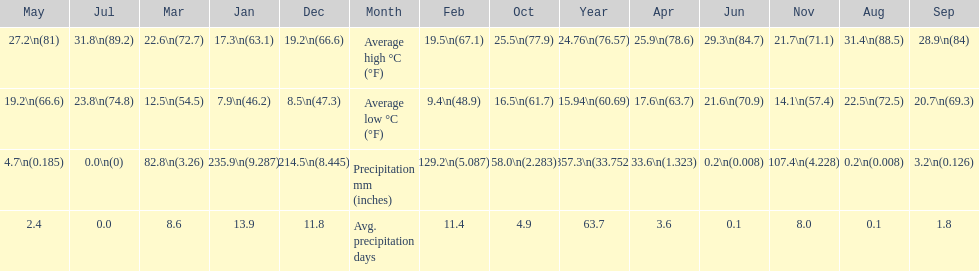Can you parse all the data within this table? {'header': ['May', 'Jul', 'Mar', 'Jan', 'Dec', 'Month', 'Feb', 'Oct', 'Year', 'Apr', 'Jun', 'Nov', 'Aug', 'Sep'], 'rows': [['27.2\\n(81)', '31.8\\n(89.2)', '22.6\\n(72.7)', '17.3\\n(63.1)', '19.2\\n(66.6)', 'Average high °C (°F)', '19.5\\n(67.1)', '25.5\\n(77.9)', '24.76\\n(76.57)', '25.9\\n(78.6)', '29.3\\n(84.7)', '21.7\\n(71.1)', '31.4\\n(88.5)', '28.9\\n(84)'], ['19.2\\n(66.6)', '23.8\\n(74.8)', '12.5\\n(54.5)', '7.9\\n(46.2)', '8.5\\n(47.3)', 'Average low °C (°F)', '9.4\\n(48.9)', '16.5\\n(61.7)', '15.94\\n(60.69)', '17.6\\n(63.7)', '21.6\\n(70.9)', '14.1\\n(57.4)', '22.5\\n(72.5)', '20.7\\n(69.3)'], ['4.7\\n(0.185)', '0.0\\n(0)', '82.8\\n(3.26)', '235.9\\n(9.287)', '214.5\\n(8.445)', 'Precipitation mm (inches)', '129.2\\n(5.087)', '58.0\\n(2.283)', '857.3\\n(33.752)', '33.6\\n(1.323)', '0.2\\n(0.008)', '107.4\\n(4.228)', '0.2\\n(0.008)', '3.2\\n(0.126)'], ['2.4', '0.0', '8.6', '13.9', '11.8', 'Avg. precipitation days', '11.4', '4.9', '63.7', '3.6', '0.1', '8.0', '0.1', '1.8']]} Which country is haifa in? Israel. 